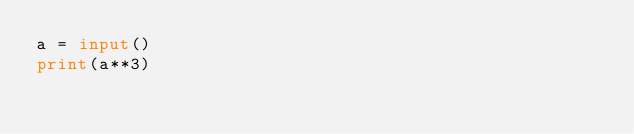<code> <loc_0><loc_0><loc_500><loc_500><_Python_>a = input()
print(a**3)</code> 